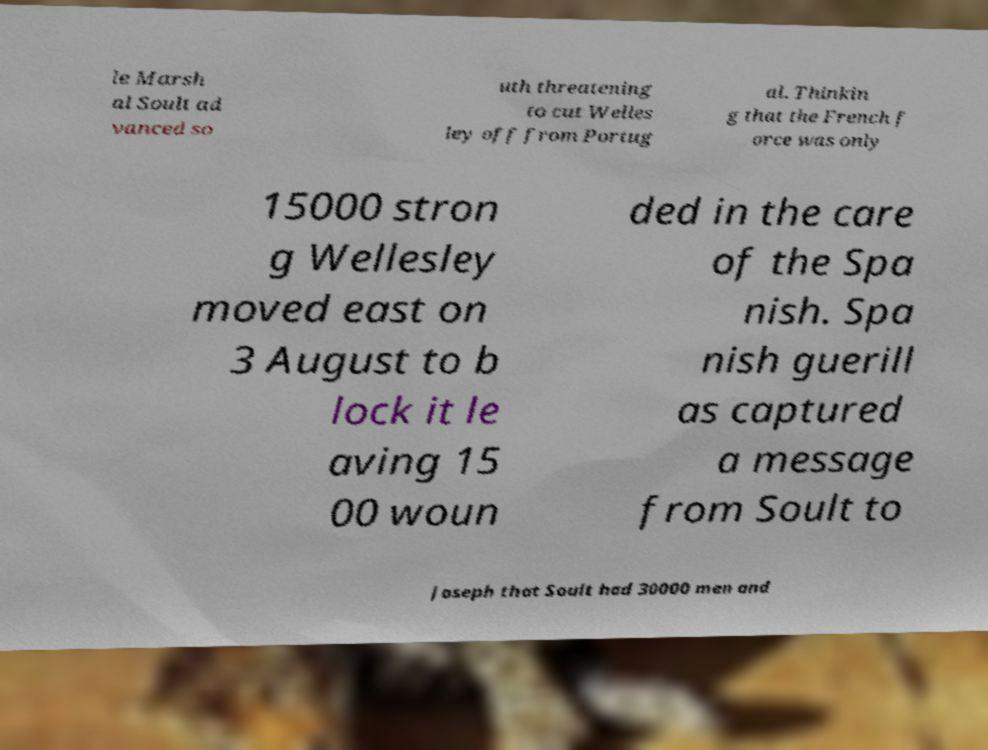There's text embedded in this image that I need extracted. Can you transcribe it verbatim? le Marsh al Soult ad vanced so uth threatening to cut Welles ley off from Portug al. Thinkin g that the French f orce was only 15000 stron g Wellesley moved east on 3 August to b lock it le aving 15 00 woun ded in the care of the Spa nish. Spa nish guerill as captured a message from Soult to Joseph that Soult had 30000 men and 